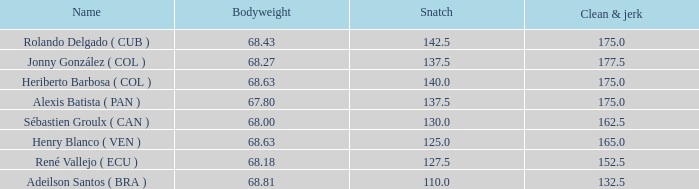Considering a total weight of 315 kg and a bodyweight of 68.63 kg, how many clean and jerk snatches surpassed 132.5? 1.0. 